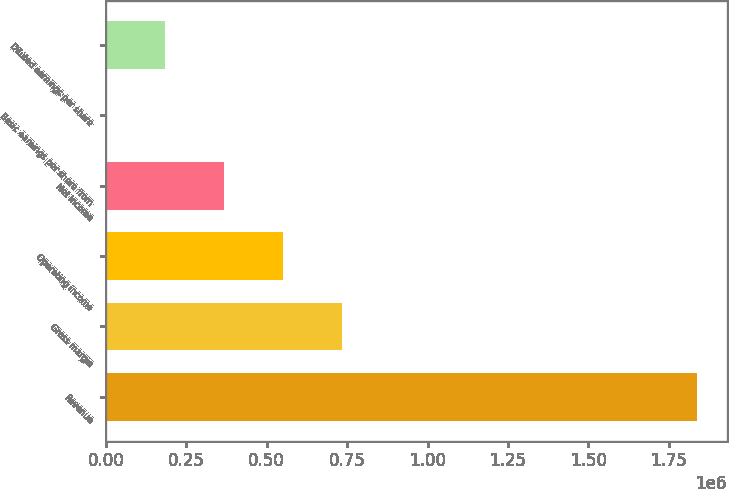Convert chart to OTSL. <chart><loc_0><loc_0><loc_500><loc_500><bar_chart><fcel>Revenue<fcel>Gross margin<fcel>Operating income<fcel>Net income<fcel>Basic earnings per share from<fcel>Diluted earnings per share<nl><fcel>1.83807e+06<fcel>735228<fcel>551421<fcel>367614<fcel>0.39<fcel>183807<nl></chart> 